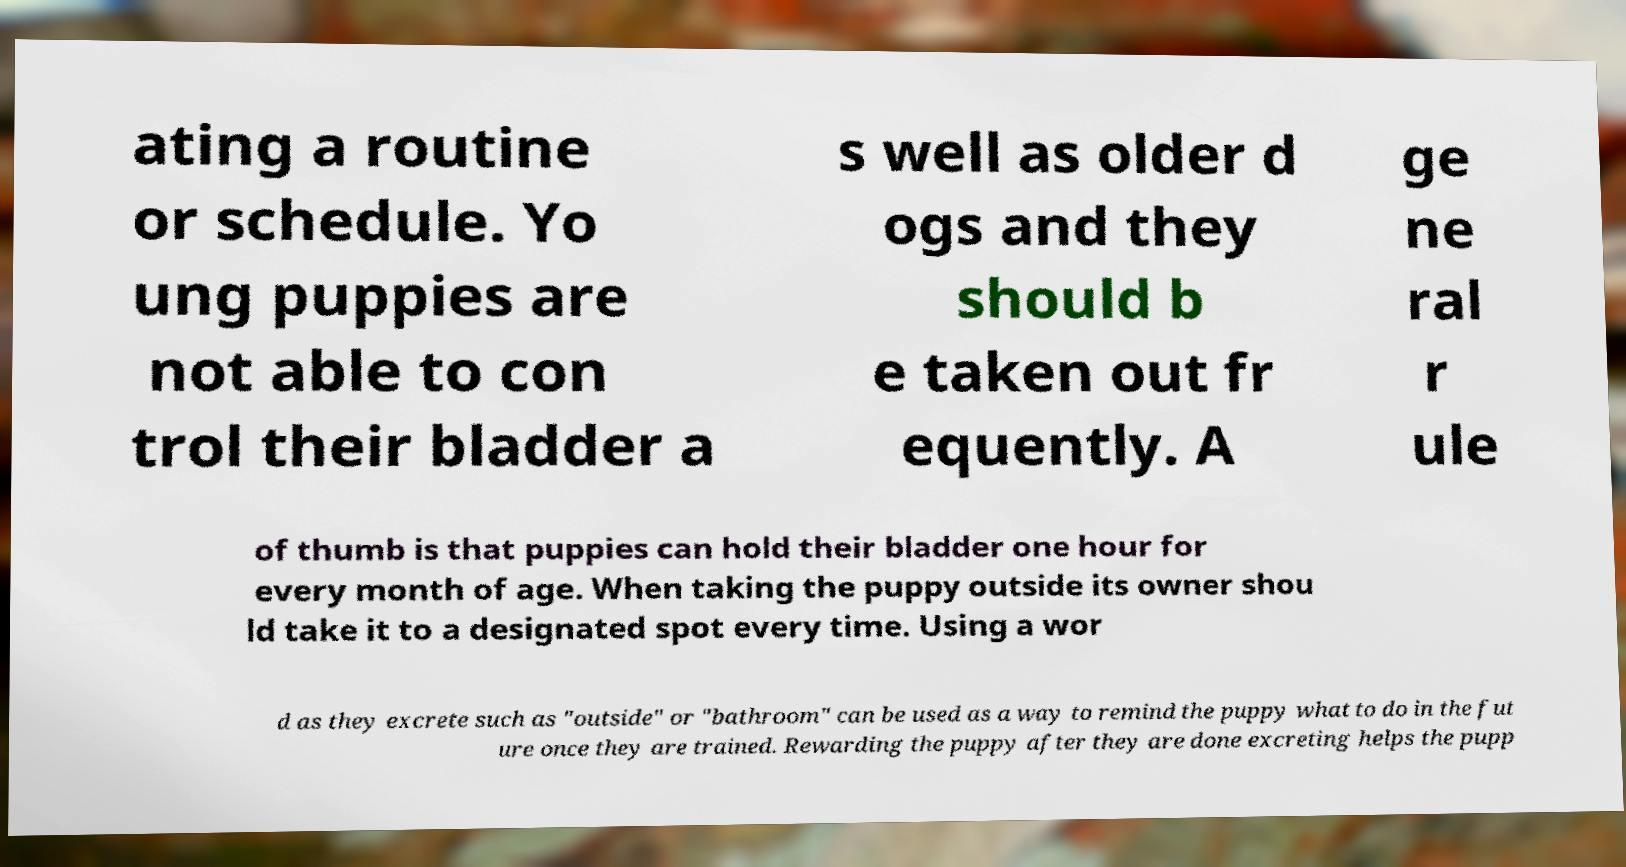Could you extract and type out the text from this image? ating a routine or schedule. Yo ung puppies are not able to con trol their bladder a s well as older d ogs and they should b e taken out fr equently. A ge ne ral r ule of thumb is that puppies can hold their bladder one hour for every month of age. When taking the puppy outside its owner shou ld take it to a designated spot every time. Using a wor d as they excrete such as "outside" or "bathroom" can be used as a way to remind the puppy what to do in the fut ure once they are trained. Rewarding the puppy after they are done excreting helps the pupp 